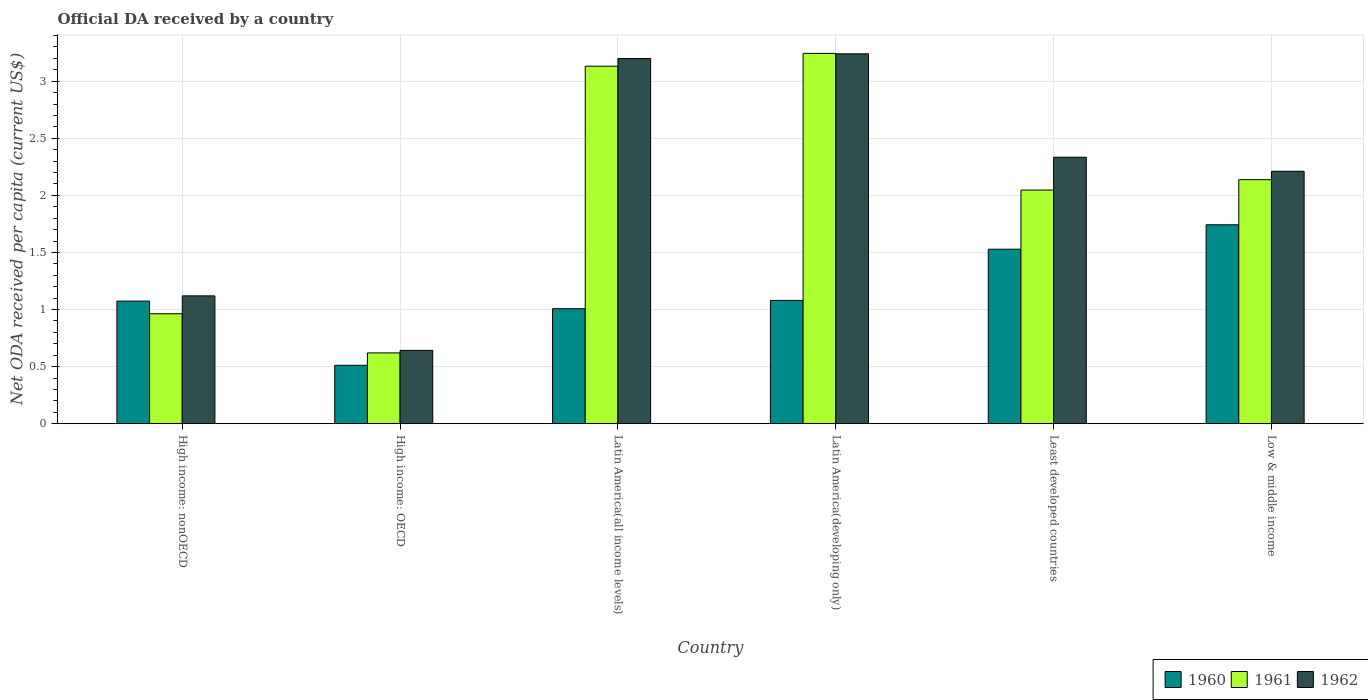Are the number of bars per tick equal to the number of legend labels?
Provide a succinct answer. Yes. How many bars are there on the 6th tick from the left?
Your answer should be compact. 3. How many bars are there on the 2nd tick from the right?
Your response must be concise. 3. What is the label of the 5th group of bars from the left?
Provide a succinct answer. Least developed countries. What is the ODA received in in 1961 in Latin America(developing only)?
Your response must be concise. 3.24. Across all countries, what is the maximum ODA received in in 1960?
Offer a terse response. 1.74. Across all countries, what is the minimum ODA received in in 1961?
Your response must be concise. 0.62. In which country was the ODA received in in 1961 maximum?
Make the answer very short. Latin America(developing only). In which country was the ODA received in in 1962 minimum?
Give a very brief answer. High income: OECD. What is the total ODA received in in 1960 in the graph?
Offer a terse response. 6.94. What is the difference between the ODA received in in 1961 in High income: nonOECD and that in Latin America(developing only)?
Offer a terse response. -2.28. What is the difference between the ODA received in in 1962 in Latin America(developing only) and the ODA received in in 1960 in High income: OECD?
Offer a very short reply. 2.73. What is the average ODA received in in 1960 per country?
Your response must be concise. 1.16. What is the difference between the ODA received in of/in 1962 and ODA received in of/in 1961 in High income: nonOECD?
Your answer should be very brief. 0.16. What is the ratio of the ODA received in in 1962 in Least developed countries to that in Low & middle income?
Offer a terse response. 1.06. Is the ODA received in in 1960 in High income: nonOECD less than that in Low & middle income?
Provide a short and direct response. Yes. What is the difference between the highest and the second highest ODA received in in 1961?
Make the answer very short. 0.99. What is the difference between the highest and the lowest ODA received in in 1960?
Your answer should be compact. 1.23. Is the sum of the ODA received in in 1962 in High income: OECD and High income: nonOECD greater than the maximum ODA received in in 1960 across all countries?
Make the answer very short. Yes. Are all the bars in the graph horizontal?
Provide a short and direct response. No. How many countries are there in the graph?
Offer a terse response. 6. Are the values on the major ticks of Y-axis written in scientific E-notation?
Offer a very short reply. No. Does the graph contain any zero values?
Your answer should be compact. No. Where does the legend appear in the graph?
Give a very brief answer. Bottom right. How are the legend labels stacked?
Your response must be concise. Horizontal. What is the title of the graph?
Offer a very short reply. Official DA received by a country. What is the label or title of the Y-axis?
Offer a terse response. Net ODA received per capita (current US$). What is the Net ODA received per capita (current US$) of 1960 in High income: nonOECD?
Give a very brief answer. 1.07. What is the Net ODA received per capita (current US$) of 1961 in High income: nonOECD?
Offer a very short reply. 0.96. What is the Net ODA received per capita (current US$) of 1962 in High income: nonOECD?
Provide a short and direct response. 1.12. What is the Net ODA received per capita (current US$) of 1960 in High income: OECD?
Your answer should be compact. 0.51. What is the Net ODA received per capita (current US$) in 1961 in High income: OECD?
Give a very brief answer. 0.62. What is the Net ODA received per capita (current US$) of 1962 in High income: OECD?
Give a very brief answer. 0.64. What is the Net ODA received per capita (current US$) of 1960 in Latin America(all income levels)?
Ensure brevity in your answer.  1.01. What is the Net ODA received per capita (current US$) in 1961 in Latin America(all income levels)?
Your answer should be compact. 3.13. What is the Net ODA received per capita (current US$) of 1962 in Latin America(all income levels)?
Offer a very short reply. 3.2. What is the Net ODA received per capita (current US$) in 1960 in Latin America(developing only)?
Provide a short and direct response. 1.08. What is the Net ODA received per capita (current US$) of 1961 in Latin America(developing only)?
Your response must be concise. 3.24. What is the Net ODA received per capita (current US$) in 1962 in Latin America(developing only)?
Give a very brief answer. 3.24. What is the Net ODA received per capita (current US$) in 1960 in Least developed countries?
Give a very brief answer. 1.53. What is the Net ODA received per capita (current US$) in 1961 in Least developed countries?
Ensure brevity in your answer.  2.05. What is the Net ODA received per capita (current US$) of 1962 in Least developed countries?
Offer a very short reply. 2.33. What is the Net ODA received per capita (current US$) in 1960 in Low & middle income?
Your response must be concise. 1.74. What is the Net ODA received per capita (current US$) in 1961 in Low & middle income?
Offer a very short reply. 2.14. What is the Net ODA received per capita (current US$) of 1962 in Low & middle income?
Offer a terse response. 2.21. Across all countries, what is the maximum Net ODA received per capita (current US$) in 1960?
Offer a terse response. 1.74. Across all countries, what is the maximum Net ODA received per capita (current US$) of 1961?
Your response must be concise. 3.24. Across all countries, what is the maximum Net ODA received per capita (current US$) in 1962?
Give a very brief answer. 3.24. Across all countries, what is the minimum Net ODA received per capita (current US$) of 1960?
Provide a short and direct response. 0.51. Across all countries, what is the minimum Net ODA received per capita (current US$) of 1961?
Your answer should be very brief. 0.62. Across all countries, what is the minimum Net ODA received per capita (current US$) of 1962?
Make the answer very short. 0.64. What is the total Net ODA received per capita (current US$) of 1960 in the graph?
Ensure brevity in your answer.  6.94. What is the total Net ODA received per capita (current US$) of 1961 in the graph?
Offer a terse response. 12.14. What is the total Net ODA received per capita (current US$) of 1962 in the graph?
Offer a terse response. 12.75. What is the difference between the Net ODA received per capita (current US$) of 1960 in High income: nonOECD and that in High income: OECD?
Provide a short and direct response. 0.56. What is the difference between the Net ODA received per capita (current US$) in 1961 in High income: nonOECD and that in High income: OECD?
Provide a succinct answer. 0.34. What is the difference between the Net ODA received per capita (current US$) of 1962 in High income: nonOECD and that in High income: OECD?
Offer a terse response. 0.48. What is the difference between the Net ODA received per capita (current US$) of 1960 in High income: nonOECD and that in Latin America(all income levels)?
Offer a terse response. 0.07. What is the difference between the Net ODA received per capita (current US$) in 1961 in High income: nonOECD and that in Latin America(all income levels)?
Give a very brief answer. -2.17. What is the difference between the Net ODA received per capita (current US$) in 1962 in High income: nonOECD and that in Latin America(all income levels)?
Offer a terse response. -2.08. What is the difference between the Net ODA received per capita (current US$) of 1960 in High income: nonOECD and that in Latin America(developing only)?
Your answer should be very brief. -0.01. What is the difference between the Net ODA received per capita (current US$) of 1961 in High income: nonOECD and that in Latin America(developing only)?
Give a very brief answer. -2.28. What is the difference between the Net ODA received per capita (current US$) of 1962 in High income: nonOECD and that in Latin America(developing only)?
Provide a succinct answer. -2.12. What is the difference between the Net ODA received per capita (current US$) of 1960 in High income: nonOECD and that in Least developed countries?
Offer a terse response. -0.45. What is the difference between the Net ODA received per capita (current US$) in 1961 in High income: nonOECD and that in Least developed countries?
Make the answer very short. -1.08. What is the difference between the Net ODA received per capita (current US$) in 1962 in High income: nonOECD and that in Least developed countries?
Keep it short and to the point. -1.21. What is the difference between the Net ODA received per capita (current US$) of 1960 in High income: nonOECD and that in Low & middle income?
Provide a short and direct response. -0.67. What is the difference between the Net ODA received per capita (current US$) in 1961 in High income: nonOECD and that in Low & middle income?
Offer a terse response. -1.17. What is the difference between the Net ODA received per capita (current US$) of 1962 in High income: nonOECD and that in Low & middle income?
Your answer should be compact. -1.09. What is the difference between the Net ODA received per capita (current US$) in 1960 in High income: OECD and that in Latin America(all income levels)?
Provide a short and direct response. -0.5. What is the difference between the Net ODA received per capita (current US$) in 1961 in High income: OECD and that in Latin America(all income levels)?
Your answer should be very brief. -2.51. What is the difference between the Net ODA received per capita (current US$) of 1962 in High income: OECD and that in Latin America(all income levels)?
Keep it short and to the point. -2.56. What is the difference between the Net ODA received per capita (current US$) in 1960 in High income: OECD and that in Latin America(developing only)?
Ensure brevity in your answer.  -0.57. What is the difference between the Net ODA received per capita (current US$) of 1961 in High income: OECD and that in Latin America(developing only)?
Offer a terse response. -2.62. What is the difference between the Net ODA received per capita (current US$) of 1962 in High income: OECD and that in Latin America(developing only)?
Offer a terse response. -2.6. What is the difference between the Net ODA received per capita (current US$) of 1960 in High income: OECD and that in Least developed countries?
Offer a very short reply. -1.02. What is the difference between the Net ODA received per capita (current US$) of 1961 in High income: OECD and that in Least developed countries?
Give a very brief answer. -1.43. What is the difference between the Net ODA received per capita (current US$) in 1962 in High income: OECD and that in Least developed countries?
Your answer should be compact. -1.69. What is the difference between the Net ODA received per capita (current US$) in 1960 in High income: OECD and that in Low & middle income?
Give a very brief answer. -1.23. What is the difference between the Net ODA received per capita (current US$) of 1961 in High income: OECD and that in Low & middle income?
Offer a very short reply. -1.52. What is the difference between the Net ODA received per capita (current US$) of 1962 in High income: OECD and that in Low & middle income?
Keep it short and to the point. -1.57. What is the difference between the Net ODA received per capita (current US$) in 1960 in Latin America(all income levels) and that in Latin America(developing only)?
Provide a succinct answer. -0.07. What is the difference between the Net ODA received per capita (current US$) of 1961 in Latin America(all income levels) and that in Latin America(developing only)?
Your answer should be very brief. -0.11. What is the difference between the Net ODA received per capita (current US$) in 1962 in Latin America(all income levels) and that in Latin America(developing only)?
Keep it short and to the point. -0.04. What is the difference between the Net ODA received per capita (current US$) in 1960 in Latin America(all income levels) and that in Least developed countries?
Give a very brief answer. -0.52. What is the difference between the Net ODA received per capita (current US$) of 1961 in Latin America(all income levels) and that in Least developed countries?
Your answer should be very brief. 1.08. What is the difference between the Net ODA received per capita (current US$) in 1962 in Latin America(all income levels) and that in Least developed countries?
Give a very brief answer. 0.86. What is the difference between the Net ODA received per capita (current US$) in 1960 in Latin America(all income levels) and that in Low & middle income?
Offer a terse response. -0.74. What is the difference between the Net ODA received per capita (current US$) in 1961 in Latin America(all income levels) and that in Low & middle income?
Your answer should be very brief. 0.99. What is the difference between the Net ODA received per capita (current US$) in 1962 in Latin America(all income levels) and that in Low & middle income?
Your answer should be very brief. 0.99. What is the difference between the Net ODA received per capita (current US$) of 1960 in Latin America(developing only) and that in Least developed countries?
Offer a terse response. -0.45. What is the difference between the Net ODA received per capita (current US$) in 1961 in Latin America(developing only) and that in Least developed countries?
Provide a succinct answer. 1.2. What is the difference between the Net ODA received per capita (current US$) in 1962 in Latin America(developing only) and that in Least developed countries?
Keep it short and to the point. 0.91. What is the difference between the Net ODA received per capita (current US$) in 1960 in Latin America(developing only) and that in Low & middle income?
Your answer should be very brief. -0.66. What is the difference between the Net ODA received per capita (current US$) of 1961 in Latin America(developing only) and that in Low & middle income?
Your response must be concise. 1.11. What is the difference between the Net ODA received per capita (current US$) in 1962 in Latin America(developing only) and that in Low & middle income?
Your answer should be compact. 1.03. What is the difference between the Net ODA received per capita (current US$) in 1960 in Least developed countries and that in Low & middle income?
Provide a succinct answer. -0.21. What is the difference between the Net ODA received per capita (current US$) of 1961 in Least developed countries and that in Low & middle income?
Give a very brief answer. -0.09. What is the difference between the Net ODA received per capita (current US$) in 1962 in Least developed countries and that in Low & middle income?
Give a very brief answer. 0.12. What is the difference between the Net ODA received per capita (current US$) of 1960 in High income: nonOECD and the Net ODA received per capita (current US$) of 1961 in High income: OECD?
Your answer should be compact. 0.45. What is the difference between the Net ODA received per capita (current US$) in 1960 in High income: nonOECD and the Net ODA received per capita (current US$) in 1962 in High income: OECD?
Your answer should be compact. 0.43. What is the difference between the Net ODA received per capita (current US$) in 1961 in High income: nonOECD and the Net ODA received per capita (current US$) in 1962 in High income: OECD?
Your response must be concise. 0.32. What is the difference between the Net ODA received per capita (current US$) in 1960 in High income: nonOECD and the Net ODA received per capita (current US$) in 1961 in Latin America(all income levels)?
Make the answer very short. -2.06. What is the difference between the Net ODA received per capita (current US$) in 1960 in High income: nonOECD and the Net ODA received per capita (current US$) in 1962 in Latin America(all income levels)?
Your response must be concise. -2.12. What is the difference between the Net ODA received per capita (current US$) in 1961 in High income: nonOECD and the Net ODA received per capita (current US$) in 1962 in Latin America(all income levels)?
Offer a very short reply. -2.24. What is the difference between the Net ODA received per capita (current US$) of 1960 in High income: nonOECD and the Net ODA received per capita (current US$) of 1961 in Latin America(developing only)?
Your answer should be very brief. -2.17. What is the difference between the Net ODA received per capita (current US$) in 1960 in High income: nonOECD and the Net ODA received per capita (current US$) in 1962 in Latin America(developing only)?
Offer a terse response. -2.17. What is the difference between the Net ODA received per capita (current US$) of 1961 in High income: nonOECD and the Net ODA received per capita (current US$) of 1962 in Latin America(developing only)?
Ensure brevity in your answer.  -2.28. What is the difference between the Net ODA received per capita (current US$) in 1960 in High income: nonOECD and the Net ODA received per capita (current US$) in 1961 in Least developed countries?
Offer a very short reply. -0.97. What is the difference between the Net ODA received per capita (current US$) of 1960 in High income: nonOECD and the Net ODA received per capita (current US$) of 1962 in Least developed countries?
Offer a very short reply. -1.26. What is the difference between the Net ODA received per capita (current US$) of 1961 in High income: nonOECD and the Net ODA received per capita (current US$) of 1962 in Least developed countries?
Make the answer very short. -1.37. What is the difference between the Net ODA received per capita (current US$) in 1960 in High income: nonOECD and the Net ODA received per capita (current US$) in 1961 in Low & middle income?
Your answer should be compact. -1.06. What is the difference between the Net ODA received per capita (current US$) of 1960 in High income: nonOECD and the Net ODA received per capita (current US$) of 1962 in Low & middle income?
Your response must be concise. -1.14. What is the difference between the Net ODA received per capita (current US$) in 1961 in High income: nonOECD and the Net ODA received per capita (current US$) in 1962 in Low & middle income?
Offer a terse response. -1.25. What is the difference between the Net ODA received per capita (current US$) of 1960 in High income: OECD and the Net ODA received per capita (current US$) of 1961 in Latin America(all income levels)?
Keep it short and to the point. -2.62. What is the difference between the Net ODA received per capita (current US$) in 1960 in High income: OECD and the Net ODA received per capita (current US$) in 1962 in Latin America(all income levels)?
Your response must be concise. -2.69. What is the difference between the Net ODA received per capita (current US$) in 1961 in High income: OECD and the Net ODA received per capita (current US$) in 1962 in Latin America(all income levels)?
Your answer should be compact. -2.58. What is the difference between the Net ODA received per capita (current US$) in 1960 in High income: OECD and the Net ODA received per capita (current US$) in 1961 in Latin America(developing only)?
Offer a terse response. -2.73. What is the difference between the Net ODA received per capita (current US$) in 1960 in High income: OECD and the Net ODA received per capita (current US$) in 1962 in Latin America(developing only)?
Give a very brief answer. -2.73. What is the difference between the Net ODA received per capita (current US$) of 1961 in High income: OECD and the Net ODA received per capita (current US$) of 1962 in Latin America(developing only)?
Offer a very short reply. -2.62. What is the difference between the Net ODA received per capita (current US$) of 1960 in High income: OECD and the Net ODA received per capita (current US$) of 1961 in Least developed countries?
Offer a very short reply. -1.53. What is the difference between the Net ODA received per capita (current US$) of 1960 in High income: OECD and the Net ODA received per capita (current US$) of 1962 in Least developed countries?
Provide a succinct answer. -1.82. What is the difference between the Net ODA received per capita (current US$) in 1961 in High income: OECD and the Net ODA received per capita (current US$) in 1962 in Least developed countries?
Give a very brief answer. -1.71. What is the difference between the Net ODA received per capita (current US$) of 1960 in High income: OECD and the Net ODA received per capita (current US$) of 1961 in Low & middle income?
Your answer should be compact. -1.63. What is the difference between the Net ODA received per capita (current US$) in 1960 in High income: OECD and the Net ODA received per capita (current US$) in 1962 in Low & middle income?
Provide a succinct answer. -1.7. What is the difference between the Net ODA received per capita (current US$) in 1961 in High income: OECD and the Net ODA received per capita (current US$) in 1962 in Low & middle income?
Offer a terse response. -1.59. What is the difference between the Net ODA received per capita (current US$) in 1960 in Latin America(all income levels) and the Net ODA received per capita (current US$) in 1961 in Latin America(developing only)?
Make the answer very short. -2.24. What is the difference between the Net ODA received per capita (current US$) in 1960 in Latin America(all income levels) and the Net ODA received per capita (current US$) in 1962 in Latin America(developing only)?
Your answer should be compact. -2.23. What is the difference between the Net ODA received per capita (current US$) in 1961 in Latin America(all income levels) and the Net ODA received per capita (current US$) in 1962 in Latin America(developing only)?
Give a very brief answer. -0.11. What is the difference between the Net ODA received per capita (current US$) of 1960 in Latin America(all income levels) and the Net ODA received per capita (current US$) of 1961 in Least developed countries?
Offer a terse response. -1.04. What is the difference between the Net ODA received per capita (current US$) of 1960 in Latin America(all income levels) and the Net ODA received per capita (current US$) of 1962 in Least developed countries?
Give a very brief answer. -1.33. What is the difference between the Net ODA received per capita (current US$) of 1961 in Latin America(all income levels) and the Net ODA received per capita (current US$) of 1962 in Least developed countries?
Make the answer very short. 0.8. What is the difference between the Net ODA received per capita (current US$) of 1960 in Latin America(all income levels) and the Net ODA received per capita (current US$) of 1961 in Low & middle income?
Keep it short and to the point. -1.13. What is the difference between the Net ODA received per capita (current US$) in 1960 in Latin America(all income levels) and the Net ODA received per capita (current US$) in 1962 in Low & middle income?
Your answer should be compact. -1.2. What is the difference between the Net ODA received per capita (current US$) of 1961 in Latin America(all income levels) and the Net ODA received per capita (current US$) of 1962 in Low & middle income?
Your response must be concise. 0.92. What is the difference between the Net ODA received per capita (current US$) in 1960 in Latin America(developing only) and the Net ODA received per capita (current US$) in 1961 in Least developed countries?
Provide a short and direct response. -0.97. What is the difference between the Net ODA received per capita (current US$) of 1960 in Latin America(developing only) and the Net ODA received per capita (current US$) of 1962 in Least developed countries?
Provide a succinct answer. -1.25. What is the difference between the Net ODA received per capita (current US$) in 1961 in Latin America(developing only) and the Net ODA received per capita (current US$) in 1962 in Least developed countries?
Provide a succinct answer. 0.91. What is the difference between the Net ODA received per capita (current US$) of 1960 in Latin America(developing only) and the Net ODA received per capita (current US$) of 1961 in Low & middle income?
Make the answer very short. -1.06. What is the difference between the Net ODA received per capita (current US$) in 1960 in Latin America(developing only) and the Net ODA received per capita (current US$) in 1962 in Low & middle income?
Your answer should be compact. -1.13. What is the difference between the Net ODA received per capita (current US$) in 1961 in Latin America(developing only) and the Net ODA received per capita (current US$) in 1962 in Low & middle income?
Offer a very short reply. 1.03. What is the difference between the Net ODA received per capita (current US$) in 1960 in Least developed countries and the Net ODA received per capita (current US$) in 1961 in Low & middle income?
Provide a short and direct response. -0.61. What is the difference between the Net ODA received per capita (current US$) of 1960 in Least developed countries and the Net ODA received per capita (current US$) of 1962 in Low & middle income?
Provide a succinct answer. -0.68. What is the difference between the Net ODA received per capita (current US$) of 1961 in Least developed countries and the Net ODA received per capita (current US$) of 1962 in Low & middle income?
Keep it short and to the point. -0.16. What is the average Net ODA received per capita (current US$) in 1960 per country?
Your answer should be compact. 1.16. What is the average Net ODA received per capita (current US$) of 1961 per country?
Offer a very short reply. 2.02. What is the average Net ODA received per capita (current US$) of 1962 per country?
Provide a short and direct response. 2.12. What is the difference between the Net ODA received per capita (current US$) in 1960 and Net ODA received per capita (current US$) in 1961 in High income: nonOECD?
Your response must be concise. 0.11. What is the difference between the Net ODA received per capita (current US$) in 1960 and Net ODA received per capita (current US$) in 1962 in High income: nonOECD?
Your answer should be very brief. -0.05. What is the difference between the Net ODA received per capita (current US$) in 1961 and Net ODA received per capita (current US$) in 1962 in High income: nonOECD?
Provide a succinct answer. -0.16. What is the difference between the Net ODA received per capita (current US$) in 1960 and Net ODA received per capita (current US$) in 1961 in High income: OECD?
Give a very brief answer. -0.11. What is the difference between the Net ODA received per capita (current US$) of 1960 and Net ODA received per capita (current US$) of 1962 in High income: OECD?
Give a very brief answer. -0.13. What is the difference between the Net ODA received per capita (current US$) of 1961 and Net ODA received per capita (current US$) of 1962 in High income: OECD?
Provide a short and direct response. -0.02. What is the difference between the Net ODA received per capita (current US$) of 1960 and Net ODA received per capita (current US$) of 1961 in Latin America(all income levels)?
Your response must be concise. -2.12. What is the difference between the Net ODA received per capita (current US$) of 1960 and Net ODA received per capita (current US$) of 1962 in Latin America(all income levels)?
Your response must be concise. -2.19. What is the difference between the Net ODA received per capita (current US$) of 1961 and Net ODA received per capita (current US$) of 1962 in Latin America(all income levels)?
Your answer should be very brief. -0.07. What is the difference between the Net ODA received per capita (current US$) in 1960 and Net ODA received per capita (current US$) in 1961 in Latin America(developing only)?
Your answer should be very brief. -2.16. What is the difference between the Net ODA received per capita (current US$) of 1960 and Net ODA received per capita (current US$) of 1962 in Latin America(developing only)?
Offer a very short reply. -2.16. What is the difference between the Net ODA received per capita (current US$) in 1961 and Net ODA received per capita (current US$) in 1962 in Latin America(developing only)?
Offer a very short reply. 0. What is the difference between the Net ODA received per capita (current US$) of 1960 and Net ODA received per capita (current US$) of 1961 in Least developed countries?
Provide a short and direct response. -0.52. What is the difference between the Net ODA received per capita (current US$) of 1960 and Net ODA received per capita (current US$) of 1962 in Least developed countries?
Your answer should be compact. -0.81. What is the difference between the Net ODA received per capita (current US$) in 1961 and Net ODA received per capita (current US$) in 1962 in Least developed countries?
Your response must be concise. -0.29. What is the difference between the Net ODA received per capita (current US$) of 1960 and Net ODA received per capita (current US$) of 1961 in Low & middle income?
Provide a short and direct response. -0.4. What is the difference between the Net ODA received per capita (current US$) in 1960 and Net ODA received per capita (current US$) in 1962 in Low & middle income?
Keep it short and to the point. -0.47. What is the difference between the Net ODA received per capita (current US$) in 1961 and Net ODA received per capita (current US$) in 1962 in Low & middle income?
Provide a short and direct response. -0.07. What is the ratio of the Net ODA received per capita (current US$) of 1960 in High income: nonOECD to that in High income: OECD?
Your answer should be compact. 2.1. What is the ratio of the Net ODA received per capita (current US$) in 1961 in High income: nonOECD to that in High income: OECD?
Keep it short and to the point. 1.55. What is the ratio of the Net ODA received per capita (current US$) in 1962 in High income: nonOECD to that in High income: OECD?
Provide a short and direct response. 1.74. What is the ratio of the Net ODA received per capita (current US$) of 1960 in High income: nonOECD to that in Latin America(all income levels)?
Ensure brevity in your answer.  1.07. What is the ratio of the Net ODA received per capita (current US$) of 1961 in High income: nonOECD to that in Latin America(all income levels)?
Provide a short and direct response. 0.31. What is the ratio of the Net ODA received per capita (current US$) in 1962 in High income: nonOECD to that in Latin America(all income levels)?
Your response must be concise. 0.35. What is the ratio of the Net ODA received per capita (current US$) of 1961 in High income: nonOECD to that in Latin America(developing only)?
Make the answer very short. 0.3. What is the ratio of the Net ODA received per capita (current US$) in 1962 in High income: nonOECD to that in Latin America(developing only)?
Your answer should be very brief. 0.35. What is the ratio of the Net ODA received per capita (current US$) in 1960 in High income: nonOECD to that in Least developed countries?
Give a very brief answer. 0.7. What is the ratio of the Net ODA received per capita (current US$) of 1961 in High income: nonOECD to that in Least developed countries?
Your answer should be very brief. 0.47. What is the ratio of the Net ODA received per capita (current US$) in 1962 in High income: nonOECD to that in Least developed countries?
Offer a very short reply. 0.48. What is the ratio of the Net ODA received per capita (current US$) of 1960 in High income: nonOECD to that in Low & middle income?
Your answer should be very brief. 0.62. What is the ratio of the Net ODA received per capita (current US$) in 1961 in High income: nonOECD to that in Low & middle income?
Make the answer very short. 0.45. What is the ratio of the Net ODA received per capita (current US$) of 1962 in High income: nonOECD to that in Low & middle income?
Give a very brief answer. 0.51. What is the ratio of the Net ODA received per capita (current US$) in 1960 in High income: OECD to that in Latin America(all income levels)?
Your response must be concise. 0.51. What is the ratio of the Net ODA received per capita (current US$) in 1961 in High income: OECD to that in Latin America(all income levels)?
Give a very brief answer. 0.2. What is the ratio of the Net ODA received per capita (current US$) of 1962 in High income: OECD to that in Latin America(all income levels)?
Offer a terse response. 0.2. What is the ratio of the Net ODA received per capita (current US$) of 1960 in High income: OECD to that in Latin America(developing only)?
Your response must be concise. 0.47. What is the ratio of the Net ODA received per capita (current US$) in 1961 in High income: OECD to that in Latin America(developing only)?
Your response must be concise. 0.19. What is the ratio of the Net ODA received per capita (current US$) in 1962 in High income: OECD to that in Latin America(developing only)?
Your answer should be compact. 0.2. What is the ratio of the Net ODA received per capita (current US$) in 1960 in High income: OECD to that in Least developed countries?
Offer a terse response. 0.33. What is the ratio of the Net ODA received per capita (current US$) in 1961 in High income: OECD to that in Least developed countries?
Your answer should be very brief. 0.3. What is the ratio of the Net ODA received per capita (current US$) of 1962 in High income: OECD to that in Least developed countries?
Offer a terse response. 0.28. What is the ratio of the Net ODA received per capita (current US$) in 1960 in High income: OECD to that in Low & middle income?
Your answer should be very brief. 0.29. What is the ratio of the Net ODA received per capita (current US$) of 1961 in High income: OECD to that in Low & middle income?
Offer a terse response. 0.29. What is the ratio of the Net ODA received per capita (current US$) in 1962 in High income: OECD to that in Low & middle income?
Your response must be concise. 0.29. What is the ratio of the Net ODA received per capita (current US$) of 1960 in Latin America(all income levels) to that in Latin America(developing only)?
Your answer should be compact. 0.93. What is the ratio of the Net ODA received per capita (current US$) of 1961 in Latin America(all income levels) to that in Latin America(developing only)?
Your answer should be very brief. 0.97. What is the ratio of the Net ODA received per capita (current US$) in 1962 in Latin America(all income levels) to that in Latin America(developing only)?
Your answer should be compact. 0.99. What is the ratio of the Net ODA received per capita (current US$) of 1960 in Latin America(all income levels) to that in Least developed countries?
Provide a short and direct response. 0.66. What is the ratio of the Net ODA received per capita (current US$) in 1961 in Latin America(all income levels) to that in Least developed countries?
Your answer should be compact. 1.53. What is the ratio of the Net ODA received per capita (current US$) of 1962 in Latin America(all income levels) to that in Least developed countries?
Keep it short and to the point. 1.37. What is the ratio of the Net ODA received per capita (current US$) of 1960 in Latin America(all income levels) to that in Low & middle income?
Offer a terse response. 0.58. What is the ratio of the Net ODA received per capita (current US$) of 1961 in Latin America(all income levels) to that in Low & middle income?
Offer a terse response. 1.46. What is the ratio of the Net ODA received per capita (current US$) in 1962 in Latin America(all income levels) to that in Low & middle income?
Keep it short and to the point. 1.45. What is the ratio of the Net ODA received per capita (current US$) of 1960 in Latin America(developing only) to that in Least developed countries?
Provide a succinct answer. 0.71. What is the ratio of the Net ODA received per capita (current US$) of 1961 in Latin America(developing only) to that in Least developed countries?
Ensure brevity in your answer.  1.58. What is the ratio of the Net ODA received per capita (current US$) in 1962 in Latin America(developing only) to that in Least developed countries?
Your answer should be very brief. 1.39. What is the ratio of the Net ODA received per capita (current US$) of 1960 in Latin America(developing only) to that in Low & middle income?
Your answer should be compact. 0.62. What is the ratio of the Net ODA received per capita (current US$) in 1961 in Latin America(developing only) to that in Low & middle income?
Your answer should be compact. 1.52. What is the ratio of the Net ODA received per capita (current US$) of 1962 in Latin America(developing only) to that in Low & middle income?
Make the answer very short. 1.47. What is the ratio of the Net ODA received per capita (current US$) of 1960 in Least developed countries to that in Low & middle income?
Your answer should be compact. 0.88. What is the ratio of the Net ODA received per capita (current US$) of 1961 in Least developed countries to that in Low & middle income?
Offer a very short reply. 0.96. What is the ratio of the Net ODA received per capita (current US$) of 1962 in Least developed countries to that in Low & middle income?
Keep it short and to the point. 1.06. What is the difference between the highest and the second highest Net ODA received per capita (current US$) in 1960?
Ensure brevity in your answer.  0.21. What is the difference between the highest and the second highest Net ODA received per capita (current US$) of 1961?
Provide a short and direct response. 0.11. What is the difference between the highest and the second highest Net ODA received per capita (current US$) in 1962?
Give a very brief answer. 0.04. What is the difference between the highest and the lowest Net ODA received per capita (current US$) of 1960?
Provide a succinct answer. 1.23. What is the difference between the highest and the lowest Net ODA received per capita (current US$) of 1961?
Your response must be concise. 2.62. What is the difference between the highest and the lowest Net ODA received per capita (current US$) of 1962?
Give a very brief answer. 2.6. 